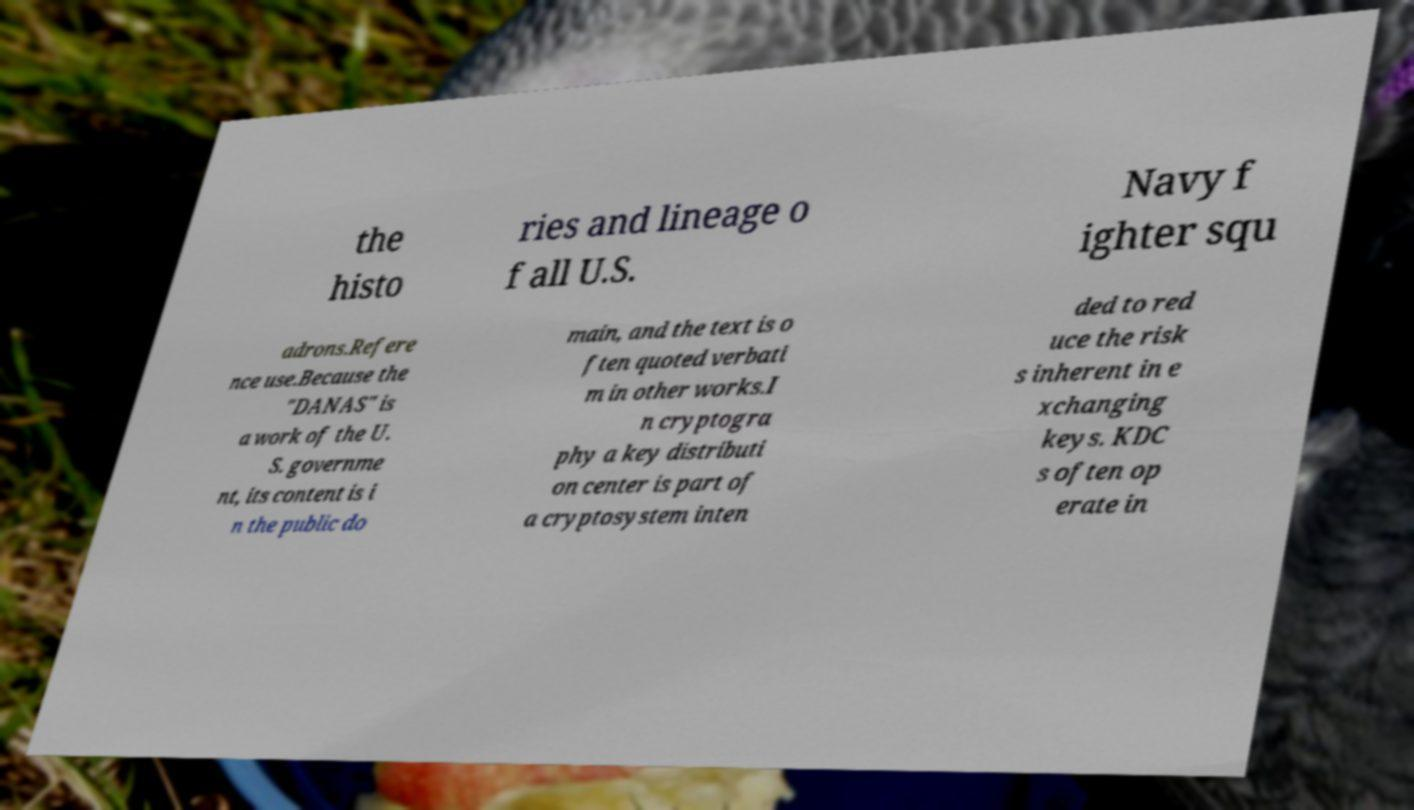Could you extract and type out the text from this image? The image contains text that appears to discuss historical data related to U.S. Navy aviation squadrons and references a work that is in the public domain due to its governmental authorship. However, the visible text is incomplete and requires context to fully understand. It also mentions a concept from cryptography, a Key Distribution Center (KDC), which is typically part of a secure communication protocol to reduce the risks associated with exchanging cryptographic keys. 